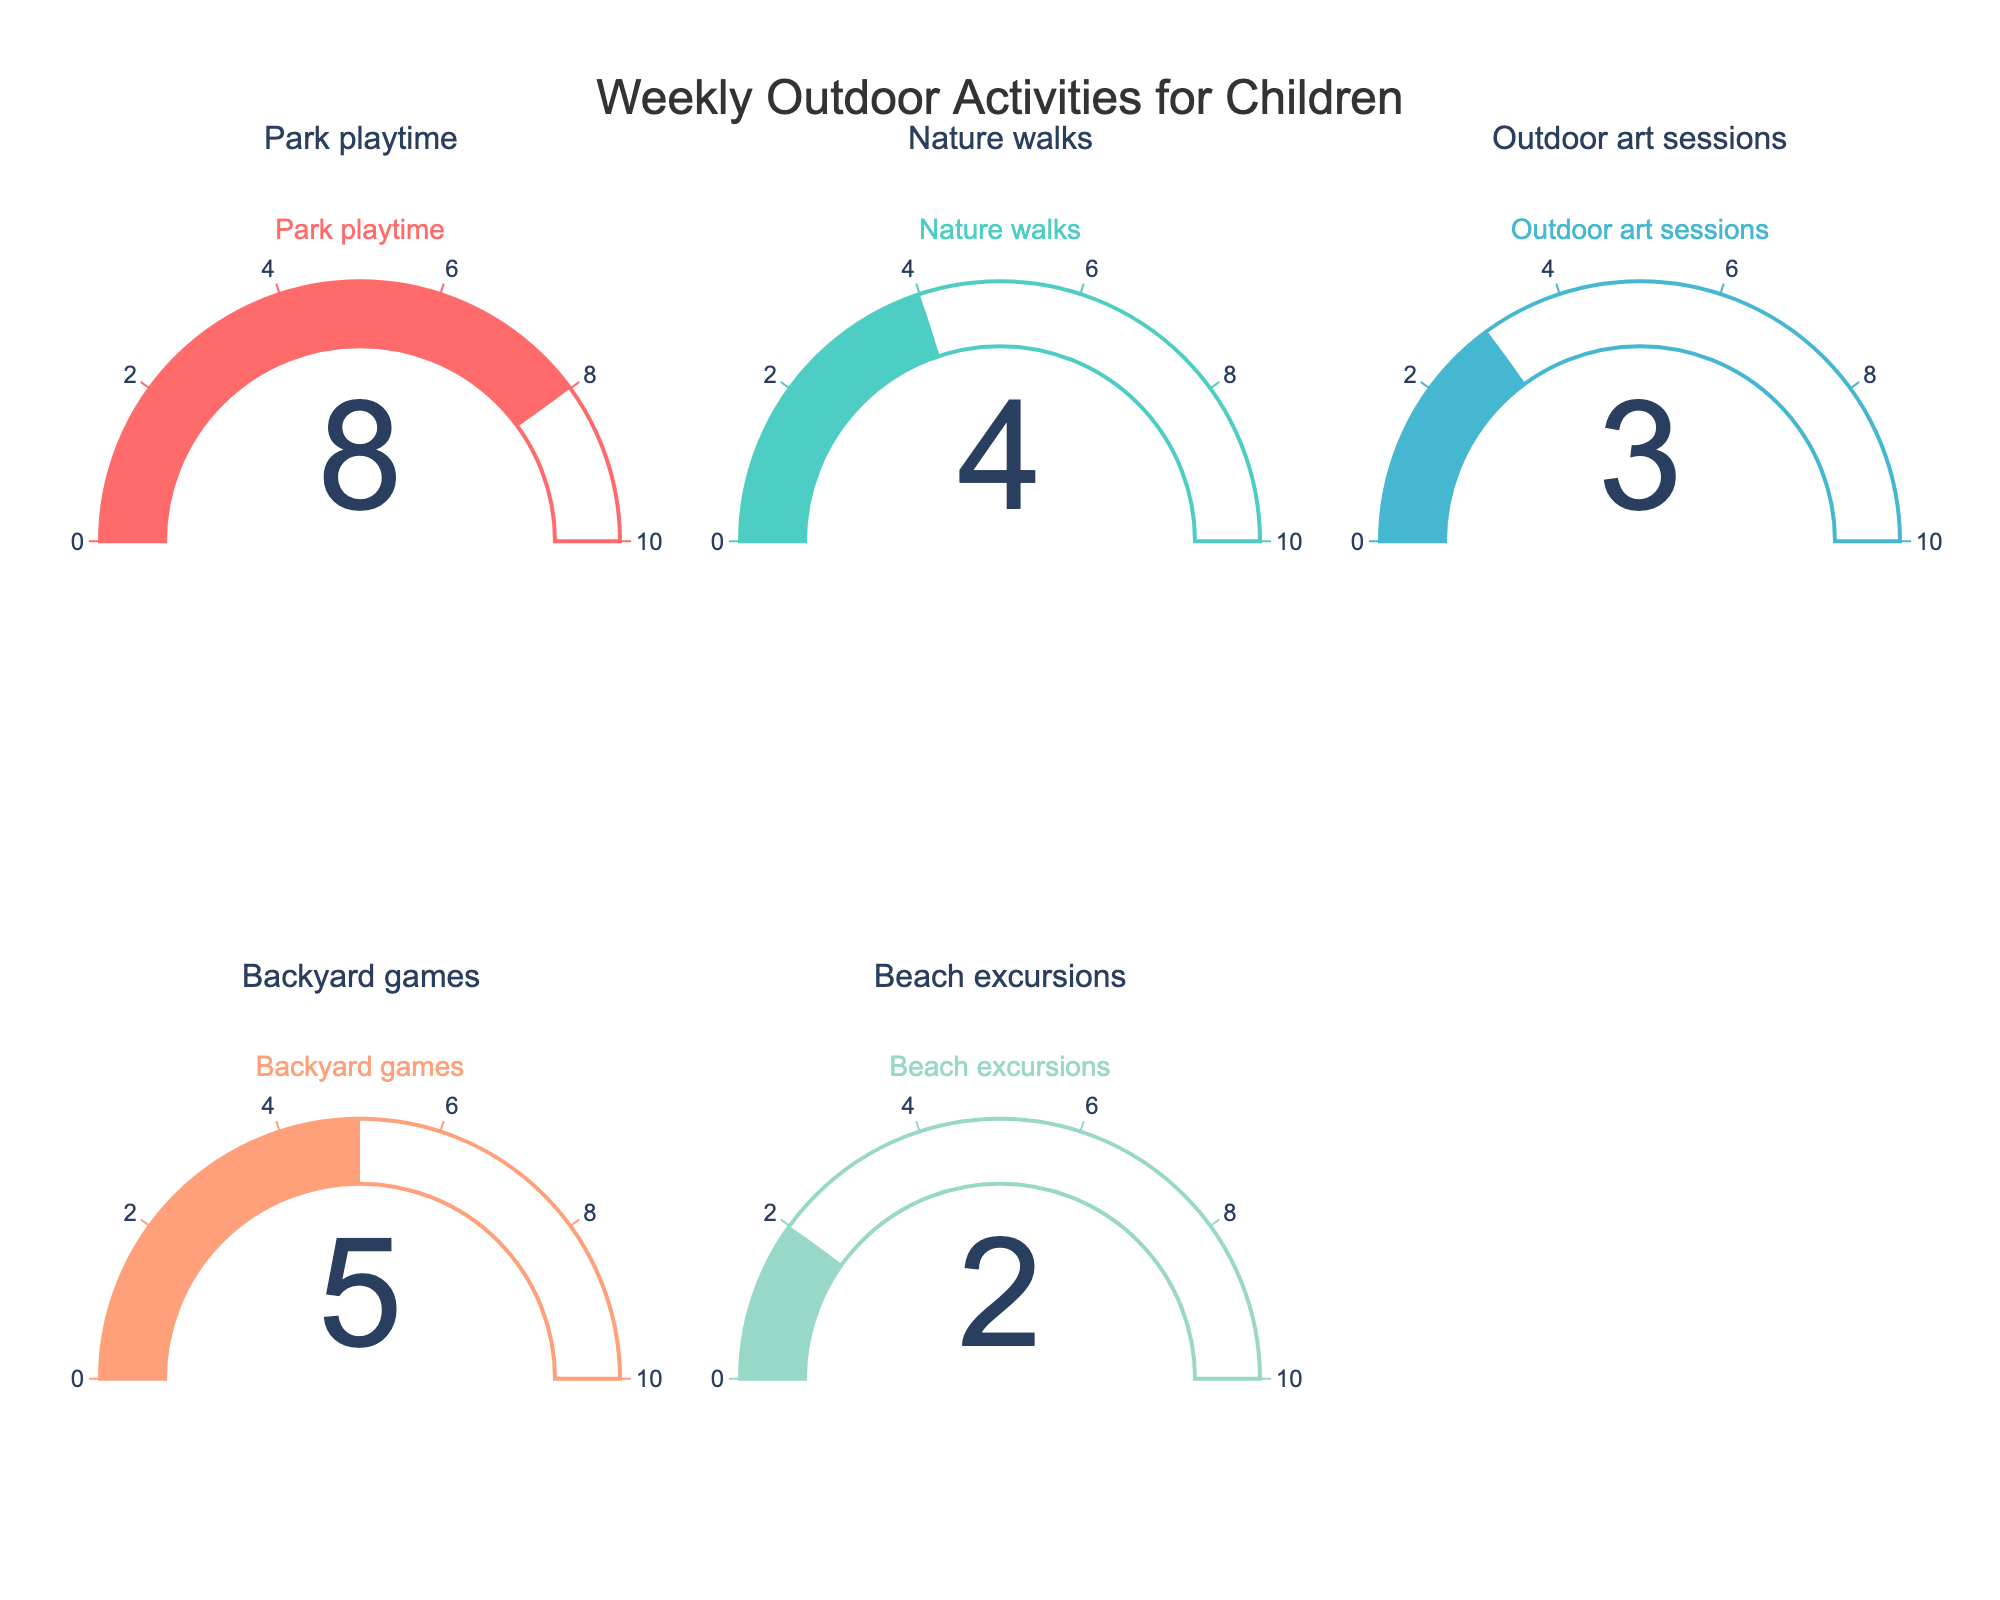Which activity has the highest number of hours spent on it? Look at each gauge and identify the one with the highest number. The Park playtime gauge shows 8 hours, which is the highest.
Answer: Park playtime What is the total number of hours spent on all outdoor activities combined? Add the hours from all gauges: Park playtime (8) + Nature walks (4) + Outdoor art sessions (3) + Backyard games (5) + Beach excursions (2) = 22 hours.
Answer: 22 Which activity took the least amount of time in hours? Look at each gauge and find the one with the lowest number. The Beach excursions gauge shows 2 hours, which is the lowest.
Answer: Beach excursions How many more hours are spent on backyard games compared to outdoor art sessions? Subtract the hours spent on outdoor art sessions from the hours spent on backyard games: 5 (backyard games) - 3 (outdoor art sessions) = 2 hours.
Answer: 2 What's the average time spent per week on each activity? Calculate the total time spent and divide it by the number of activities: (8 + 4 + 3 + 5 + 2) / 5 = 22 / 5 = 4.4 hours.
Answer: 4.4 How does the time spent on nature walks compare to beach excursions? Compare the hours spent on nature walks and beach excursions. Nature walks has 4 hours and Beach excursions has 2 hours, so nature walks has more.
Answer: Nature walks has more If we doubled the time spent on beach excursions, how would it compare to nature walks? Double the hours of beach excursions: 2 * 2 = 4 hours. Then compare it to nature walks, which also has 4 hours. They would be equal.
Answer: Equal What percentage of the total outdoor activity time is spent on park playtime? Calculate the percentage: (hours spent on park playtime / total hours spent on all activities) * 100 = (8 / 22) * 100 ≈ 36.36%.
Answer: ~36.36% Which two activities combined have the same total time as park playtime alone? Check combinations of activities to see which pair adds up to 8. Outdoor art sessions (3) + Backyard games (5) = 8.
Answer: Outdoor art sessions and Backyard games 